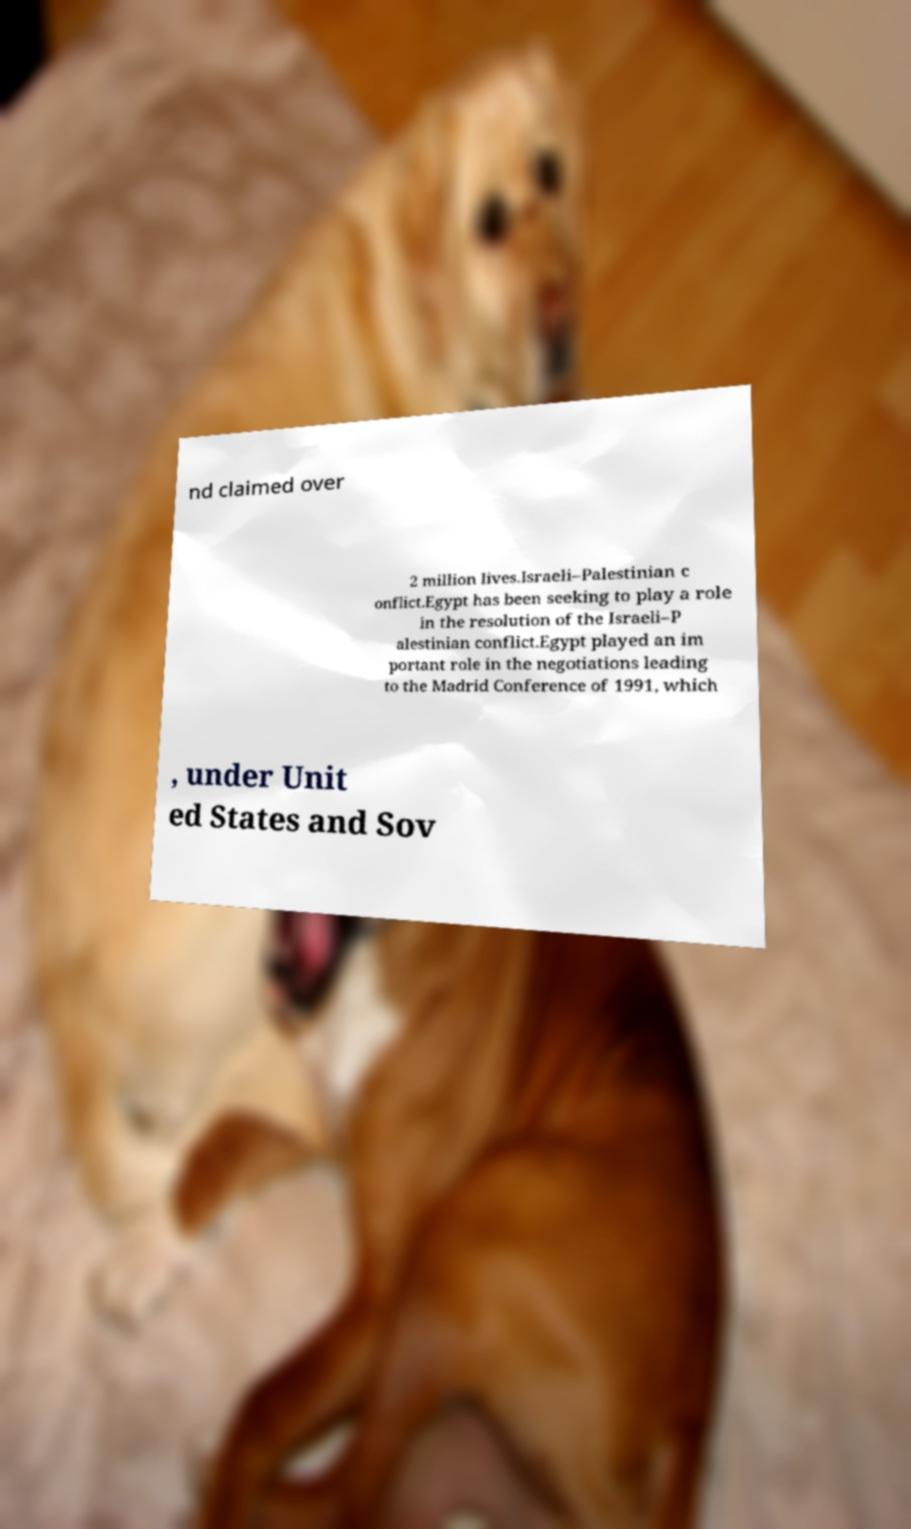Can you read and provide the text displayed in the image?This photo seems to have some interesting text. Can you extract and type it out for me? nd claimed over 2 million lives.Israeli–Palestinian c onflict.Egypt has been seeking to play a role in the resolution of the Israeli–P alestinian conflict.Egypt played an im portant role in the negotiations leading to the Madrid Conference of 1991, which , under Unit ed States and Sov 